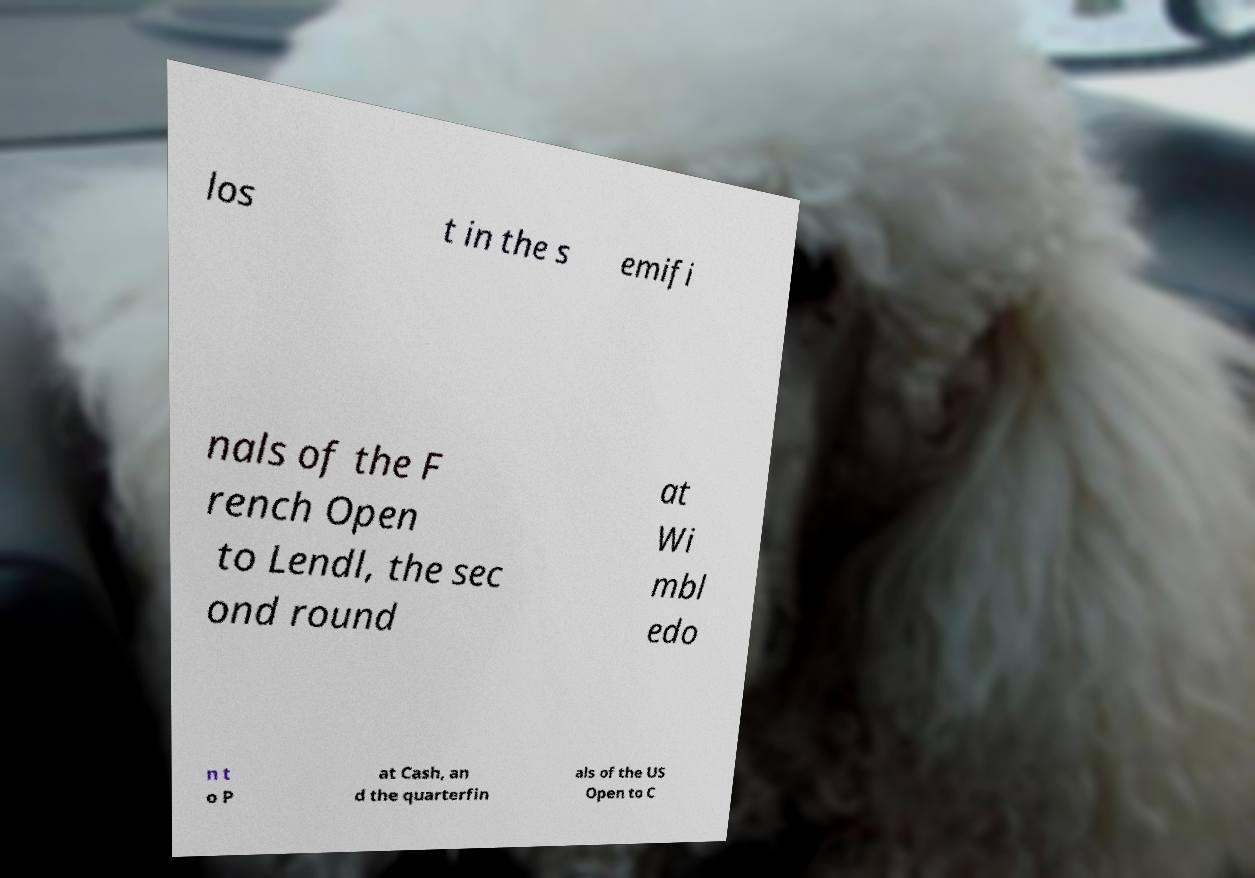Could you assist in decoding the text presented in this image and type it out clearly? los t in the s emifi nals of the F rench Open to Lendl, the sec ond round at Wi mbl edo n t o P at Cash, an d the quarterfin als of the US Open to C 